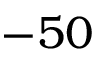<formula> <loc_0><loc_0><loc_500><loc_500>- 5 0</formula> 